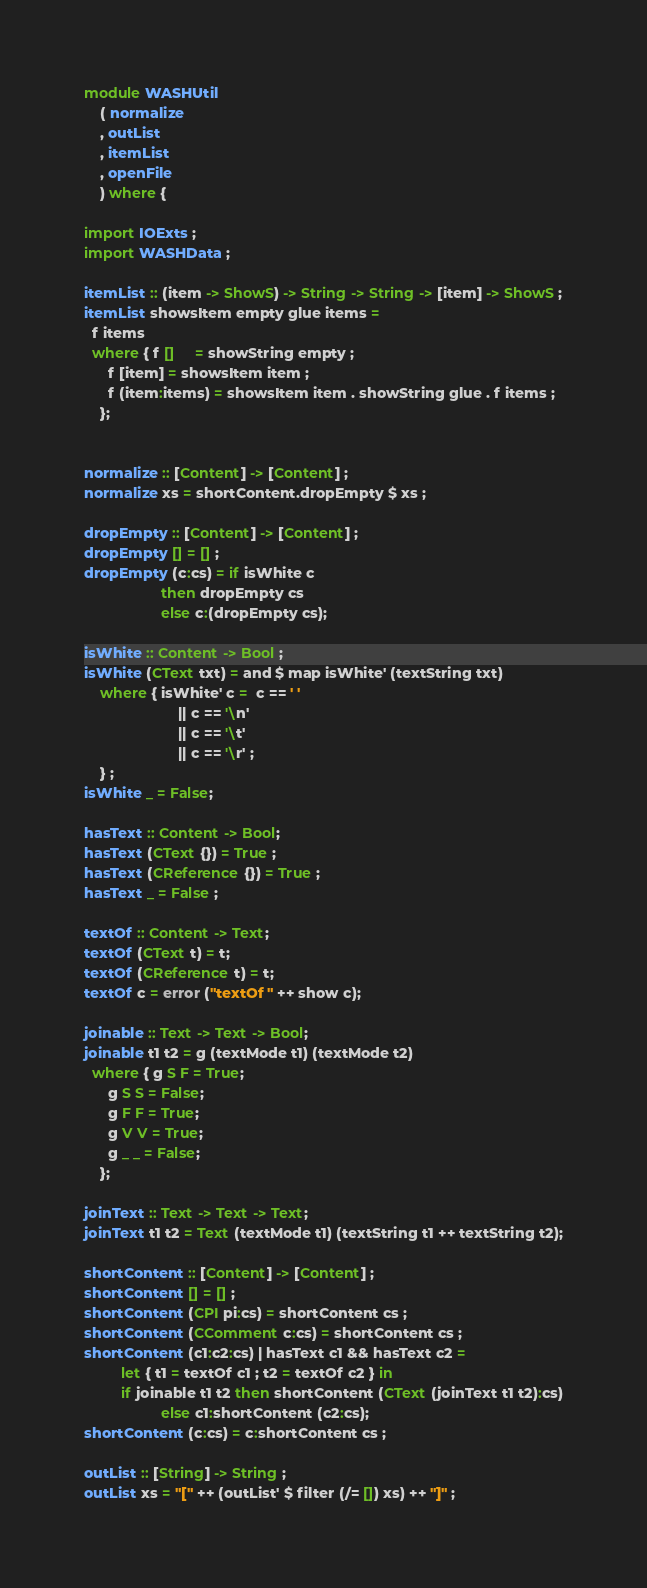<code> <loc_0><loc_0><loc_500><loc_500><_Haskell_>module WASHUtil 
    ( normalize
    , outList
    , itemList
    , openFile
    ) where {

import IOExts ;
import WASHData ;

itemList :: (item -> ShowS) -> String -> String -> [item] -> ShowS ;
itemList showsItem empty glue items =
  f items 
  where { f []     = showString empty ;
	  f [item] = showsItem item ;
	  f (item:items) = showsItem item . showString glue . f items ;
	};


normalize :: [Content] -> [Content] ;
normalize xs = shortContent.dropEmpty $ xs ;

dropEmpty :: [Content] -> [Content] ;
dropEmpty [] = [] ;
dropEmpty (c:cs) = if isWhite c 
                   then dropEmpty cs 
                   else c:(dropEmpty cs);

isWhite :: Content -> Bool ;
isWhite (CText txt) = and $ map isWhite' (textString txt)
    where { isWhite' c =  c == ' '
                       || c == '\n'
                       || c == '\t'
                       || c == '\r' ;
    } ;
isWhite _ = False;

hasText :: Content -> Bool;
hasText (CText {}) = True ;
hasText (CReference {}) = True ;
hasText _ = False ;

textOf :: Content -> Text;
textOf (CText t) = t;
textOf (CReference t) = t;
textOf c = error ("textOf " ++ show c);

joinable :: Text -> Text -> Bool;
joinable t1 t2 = g (textMode t1) (textMode t2)
  where { g S F = True;
	  g S S = False;
	  g F F = True;
	  g V V = True;
	  g _ _ = False;
	};

joinText :: Text -> Text -> Text;
joinText t1 t2 = Text (textMode t1) (textString t1 ++ textString t2);

shortContent :: [Content] -> [Content] ;
shortContent [] = [] ;
shortContent (CPI pi:cs) = shortContent cs ;
shortContent (CComment c:cs) = shortContent cs ;
shortContent (c1:c2:cs) | hasText c1 && hasText c2 =
	     let { t1 = textOf c1 ; t2 = textOf c2 } in
	     if joinable t1 t2 then shortContent (CText (joinText t1 t2):cs)
			       else c1:shortContent (c2:cs);
shortContent (c:cs) = c:shortContent cs ;

outList :: [String] -> String ;
outList xs = "[" ++ (outList' $ filter (/= []) xs) ++ "]" ;
</code> 